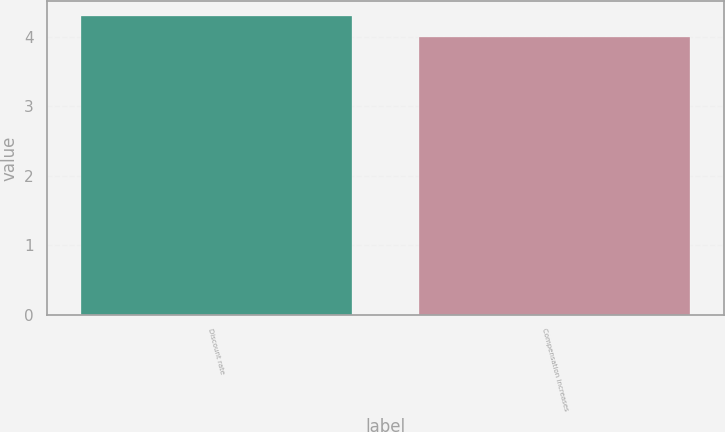Convert chart to OTSL. <chart><loc_0><loc_0><loc_500><loc_500><bar_chart><fcel>Discount rate<fcel>Compensation increases<nl><fcel>4.3<fcel>4<nl></chart> 